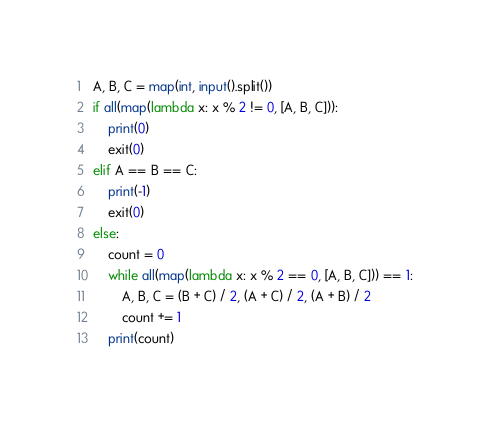Convert code to text. <code><loc_0><loc_0><loc_500><loc_500><_Python_>A, B, C = map(int, input().split())
if all(map(lambda x: x % 2 != 0, [A, B, C])):
    print(0)
    exit(0)
elif A == B == C:
    print(-1)
    exit(0)
else:
    count = 0
    while all(map(lambda x: x % 2 == 0, [A, B, C])) == 1:
        A, B, C = (B + C) / 2, (A + C) / 2, (A + B) / 2
        count += 1
    print(count)
</code> 